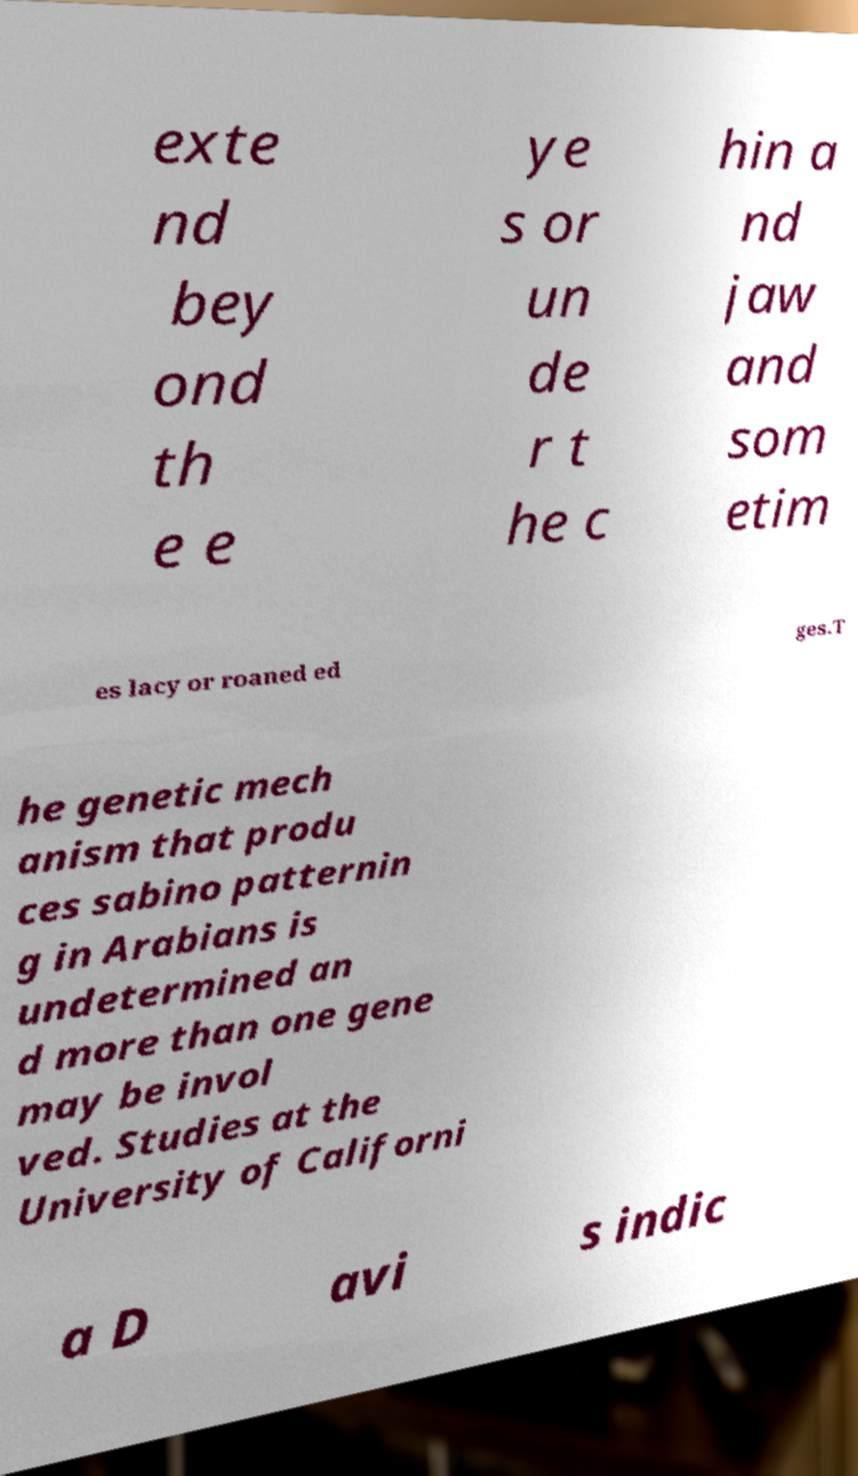Could you assist in decoding the text presented in this image and type it out clearly? exte nd bey ond th e e ye s or un de r t he c hin a nd jaw and som etim es lacy or roaned ed ges.T he genetic mech anism that produ ces sabino patternin g in Arabians is undetermined an d more than one gene may be invol ved. Studies at the University of Californi a D avi s indic 